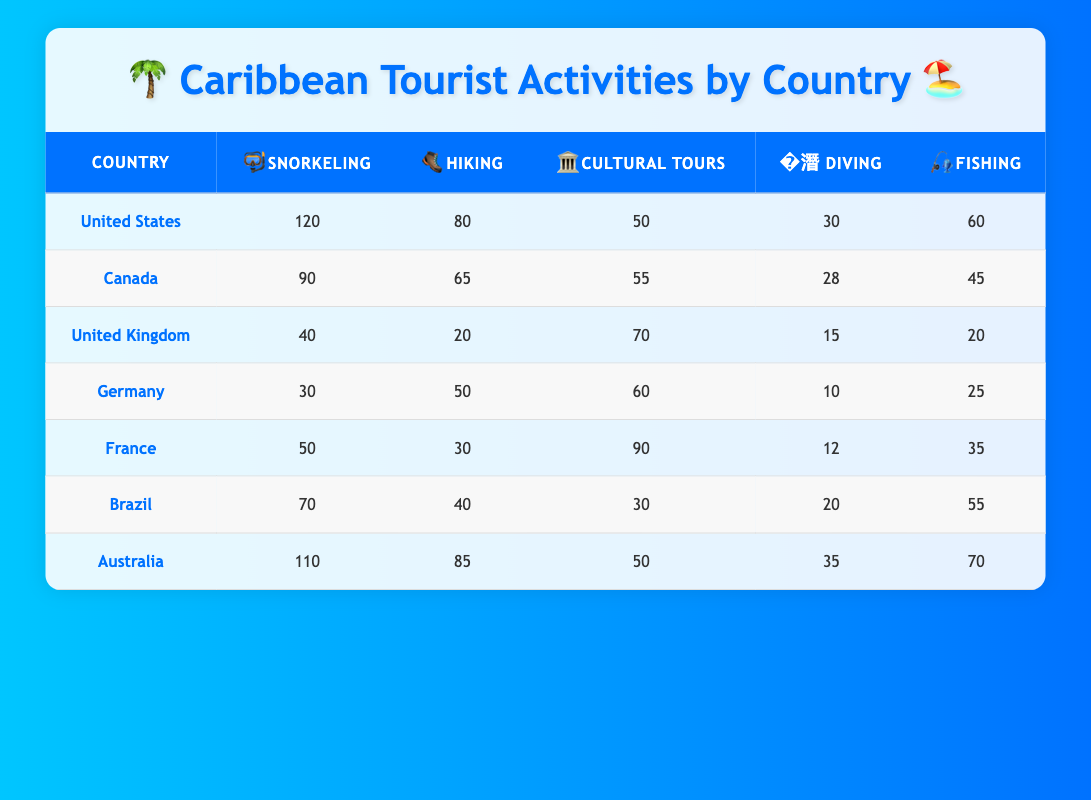What country booked the most snorkeling activities? Looking at the table, the United States has the highest number of snorkeling activities booked with a total of 120.
Answer: United States Which country booked fewer fishing activities, Canada or Germany? Canada booked 45 fishing activities, while Germany booked 25. Since 25 is less than 45, Germany booked fewer fishing activities.
Answer: Germany What is the total number of cultural tours booked by all countries combined? Adding the cultural tours: 50 + 55 + 70 + 60 + 90 + 30 + 50 = 405. Thus, the total number of cultural tours booked is 405.
Answer: 405 Is it true that Australia has the highest number of hiking activities booked? Checking the hiking activities, Australia has 85, which is more than any other country listed. Hence, it is true that Australia has the highest number of hiking activities booked.
Answer: Yes What is the average number of diving activities booked across all countries? Summing the diving activities: 30 + 28 + 15 + 10 + 12 + 20 + 35 = 150. There are 7 countries, so the average is 150/7 ≈ 21.43. Thus, the average number of diving activities is approximately 21.43.
Answer: 21.43 How many more snorkeling activities did the United States book compared to the United Kingdom? The United States booked 120 snorkeling activities, while the United Kingdom booked 40. The difference is 120 - 40 = 80. So, the United States booked 80 more snorkeling activities.
Answer: 80 Which country has the second-highest number of cultural tours booked? The countries and their cultural tours in descending order are: France (90), United Kingdom (70), Germany (60), Canada (55), Brazil (30), and Australia (50). Therefore, the second-highest is the United Kingdom with 70 cultural tours booked.
Answer: United Kingdom What is the total number of activities booked by Brazil? Adding all activities booked by Brazil: 70 (snorkeling) + 40 (hiking) + 30 (cultural tours) + 20 (diving) + 55 (fishing) = 215. Thus, Brazil booked a total of 215 activities.
Answer: 215 